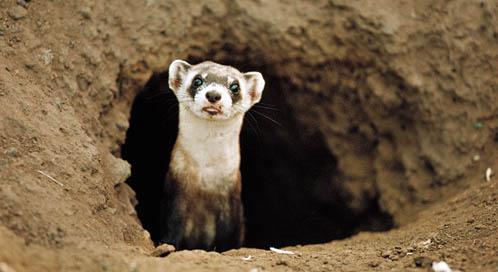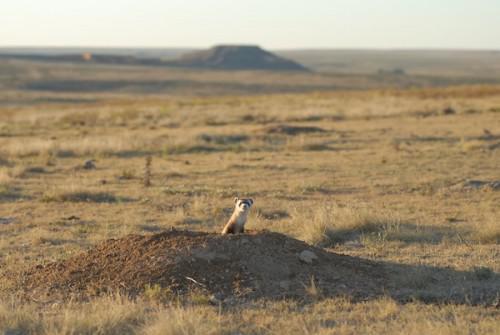The first image is the image on the left, the second image is the image on the right. Evaluate the accuracy of this statement regarding the images: "In both images, the ferret's head is stretched up to gaze about.". Is it true? Answer yes or no. Yes. The first image is the image on the left, the second image is the image on the right. Considering the images on both sides, is "An animal in one image is caught leaping in mid-air." valid? Answer yes or no. No. 